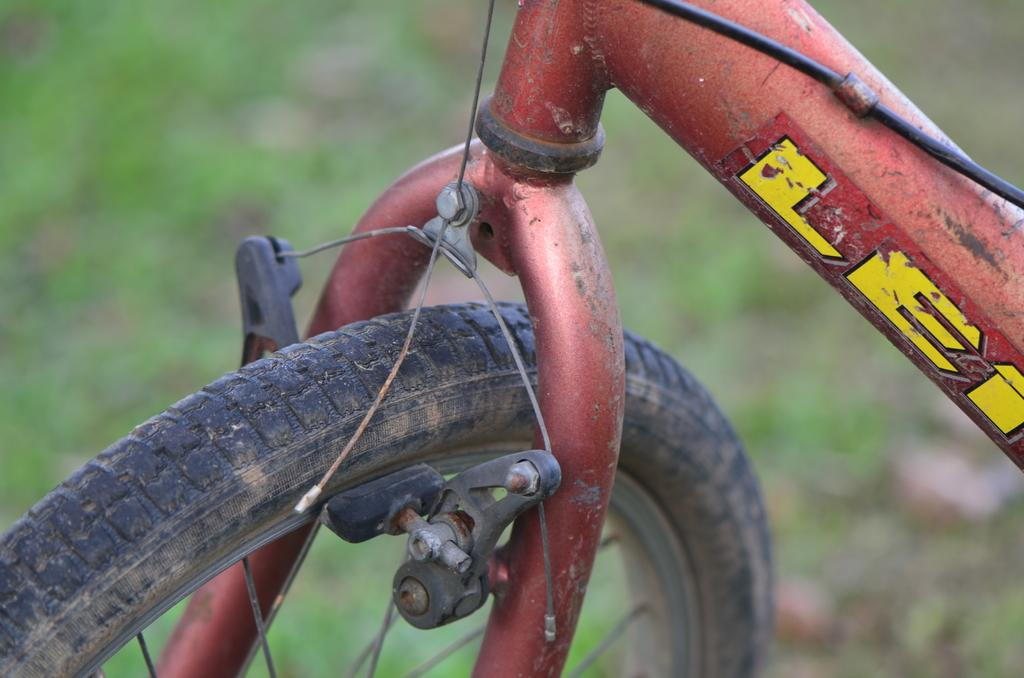What is the main object in the foreground of the image? There is a bicycle in the foreground of the image. What can be seen in the background of the image? There is greenery in the background of the image. What type of jelly can be seen dripping from the handlebars of the bicycle in the image? There is no jelly present in the image, and therefore no such activity can be observed. 